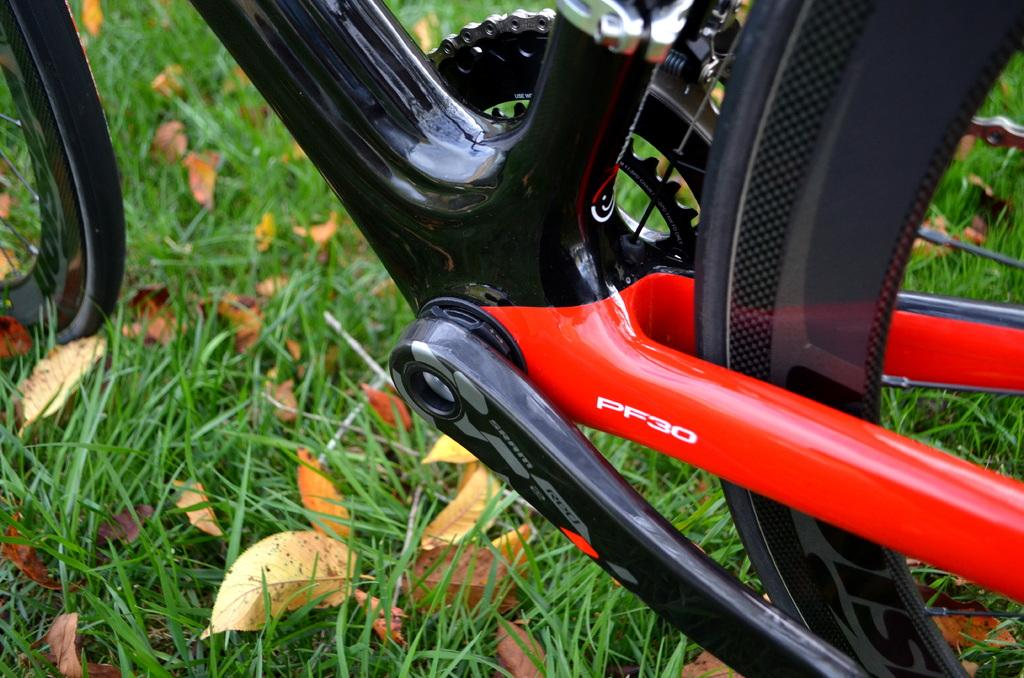What is the main object in the image? There is a bicycle in the image. What type of terrain is visible in the image? There is grass visible in the image. What type of plant material can be seen in the image? There are leaves in the image. What type of humor can be seen in the image? There is no humor present in the image; it is a straightforward depiction of a bicycle, grass, and leaves. 